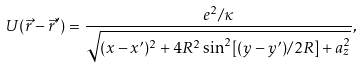<formula> <loc_0><loc_0><loc_500><loc_500>U ( \vec { r } - \vec { r } ^ { \prime } ) = \frac { e ^ { 2 } / \kappa } { \sqrt { ( x - x ^ { \prime } ) ^ { 2 } + 4 R ^ { 2 } \sin ^ { 2 } [ ( y - y ^ { \prime } ) / 2 R ] + a _ { z } ^ { 2 } } } ,</formula> 